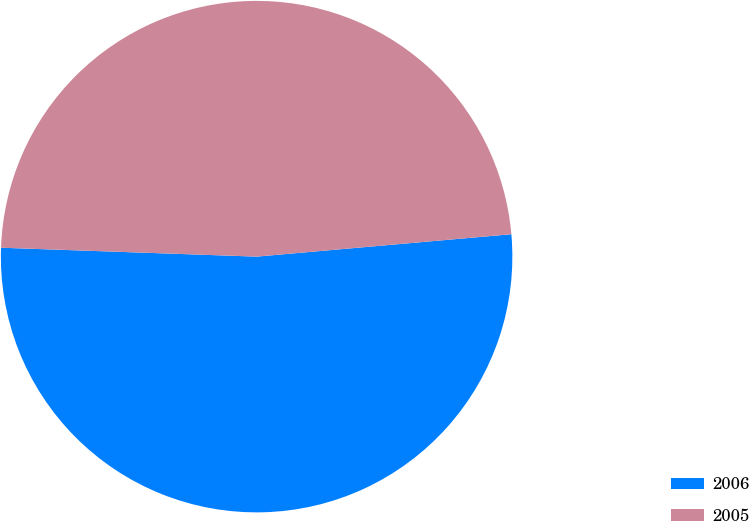<chart> <loc_0><loc_0><loc_500><loc_500><pie_chart><fcel>2006<fcel>2005<nl><fcel>51.95%<fcel>48.05%<nl></chart> 